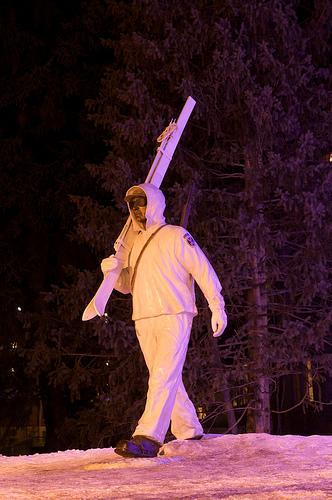What type of footwear does the man have on? The man is wearing thick black snow boots. What is the primary subject in the image performing? The main subject, a man, is walking through woods with skis over his shoulder, dressed in white and wearing snow boots. Describe the surface of the snow under the man's shoe. The snow under the man's shoe has a gravelly surface. Identify the main object in the image and describe its appearance. The primary object is a man walking through woods carrying a pair of long skis on his shoulder, wearing a white outfit and black snow boots. State the presence of any distinct patches on the man's clothing. The man has a patch on his sleeve and a patch on his suit. Verbalize the condition of the environment in the image. The environment features a snow-covered ground, evergreen trees in the background that appear purple in the light, and a lodge or house in the distance. Examine the image and describe the lighting condition. The entire photo appears to have a purple tint, with light shining through the trees and a street light visible in the distance. What is the man in the image wearing on his hands? The man is wearing white hand gloves on his hands. Mention the accessory the man in the image has on his face. The man is wearing snow goggles on his face. Can you find the yellow umbrella in the image? It's right beside the man carrying the skis. No, it's not mentioned in the image. What kind of footwear is the man wearing? thick black snow boots Which object occupies the position X:167 Y:429? snow covered ground Lay out a brief summary of the man's action in the photo. man walking through the woods carrying long skis over his shoulder In a sentence or two, describe the overall scene in the image. A man carrying skis walks through the snow-covered woods. The scene looks like nighttime, and the entire photo appears to be in purple tint. Examine the image and state the position of the man's arm. arm to side with curved hand What are some objects located on the ground in the image? snow covered ground and gravelly surface under the shoe What is behind the skier? trees and a building How does the man look in the image? determined Describe the surface under the man's shoe. gravelly surface of snow Select the most accurate description of the man's action. Options: a) Drinking tea b) Carrying skis and walking through the woods c) Swimming in a pool b) Carrying skis and walking through the woods Shoot a quick description of the skier's strap. a leather strap across his chest Based on the information provided, is it day or night in the image? night State the color of the hand gloves. white List three things the man is wearing. white outfit, black snow boots, and goggles What is the man carrying over his shoulder? a set of wooden skis Is the man wearing gloves? If so, what color are they? Yes, white gloves What is special about the lights in the background? they appear through the trees Analyze the color of the evergreen trees according to the image. purple in the light Identify the material and color of the man's outfit. shiny white material 